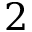<formula> <loc_0><loc_0><loc_500><loc_500>2</formula> 